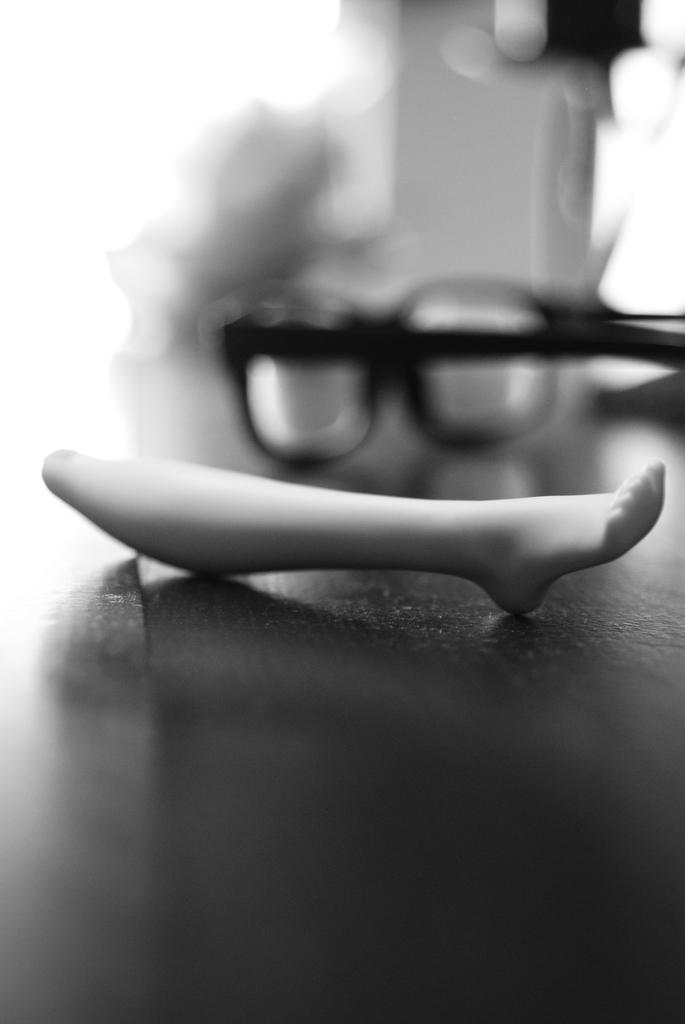What object is the main focus of the image? There is a white color toy leg in the image. Where is the toy leg located? The toy leg is on a surface. What can be seen in the background of the image? There is a spectacle in the background of the image. How would you describe the background of the image? The background of the image is blurred. What type of beef is being cooked in the image? There is no beef present in the image; it features a white color toy leg on a surface with a blurred background and a spectacle in the background. 